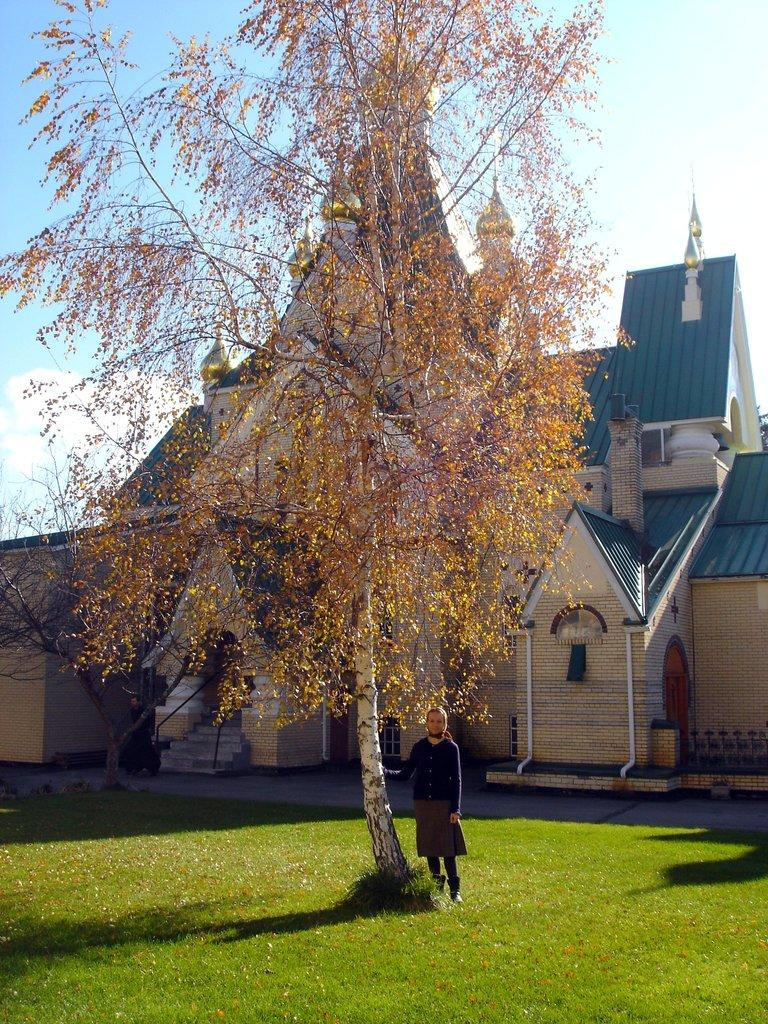Who is present in the image? There is a lady in the image. What is the lady doing in the image? The lady is standing beside a tree. What type of surface is the tree on? The tree is on a grass floor. What can be seen in the background of the image? There is a house in the background of the image. What type of sofa is visible in the image? There is no sofa present in the image. What list is the lady holding in the image? The lady is not holding any list in the image. 